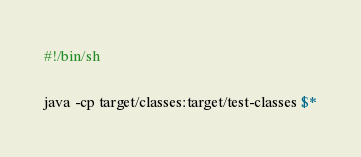Convert code to text. <code><loc_0><loc_0><loc_500><loc_500><_Bash_>#!/bin/sh

java -cp target/classes:target/test-classes $*
</code> 